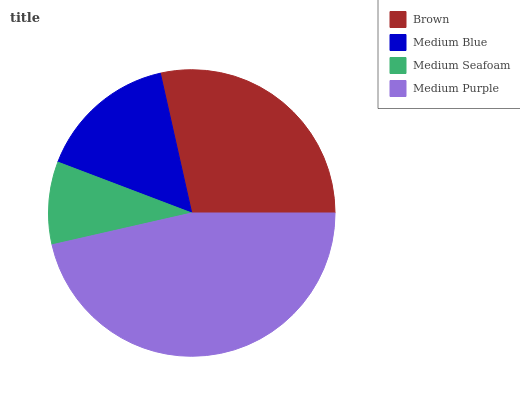Is Medium Seafoam the minimum?
Answer yes or no. Yes. Is Medium Purple the maximum?
Answer yes or no. Yes. Is Medium Blue the minimum?
Answer yes or no. No. Is Medium Blue the maximum?
Answer yes or no. No. Is Brown greater than Medium Blue?
Answer yes or no. Yes. Is Medium Blue less than Brown?
Answer yes or no. Yes. Is Medium Blue greater than Brown?
Answer yes or no. No. Is Brown less than Medium Blue?
Answer yes or no. No. Is Brown the high median?
Answer yes or no. Yes. Is Medium Blue the low median?
Answer yes or no. Yes. Is Medium Seafoam the high median?
Answer yes or no. No. Is Medium Seafoam the low median?
Answer yes or no. No. 